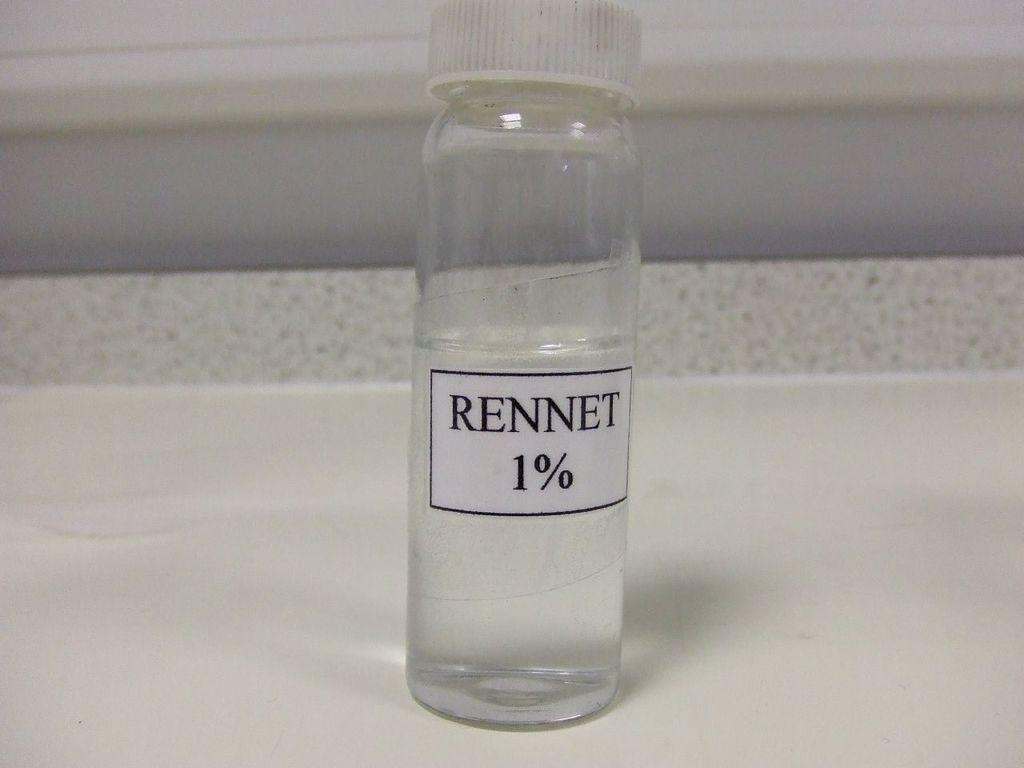<image>
Give a short and clear explanation of the subsequent image. a small bottle that is labeled as 'rennet 1%' 